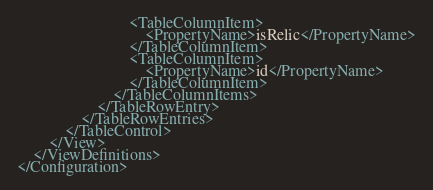Convert code to text. <code><loc_0><loc_0><loc_500><loc_500><_XML_>                            <TableColumnItem>
                                <PropertyName>isRelic</PropertyName>
                            </TableColumnItem>
                            <TableColumnItem>
                                <PropertyName>id</PropertyName>
                            </TableColumnItem>                            
                        </TableColumnItems>
                    </TableRowEntry>
                </TableRowEntries>
            </TableControl>
        </View>
    </ViewDefinitions>
</Configuration></code> 